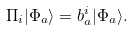Convert formula to latex. <formula><loc_0><loc_0><loc_500><loc_500>\Pi _ { i } | \Phi _ { a } \rangle = b _ { a } ^ { i } | \Phi _ { a } \rangle .</formula> 